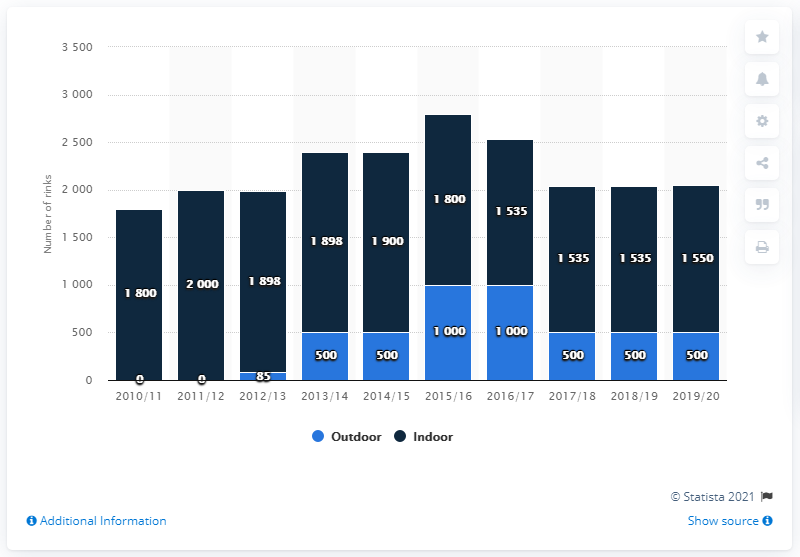Highlight a few significant elements in this photo. In two years, the number of ice rinks was zero. The difference between the highest outdoor temperature and the lowest indoor temperature is 2000 degrees. 